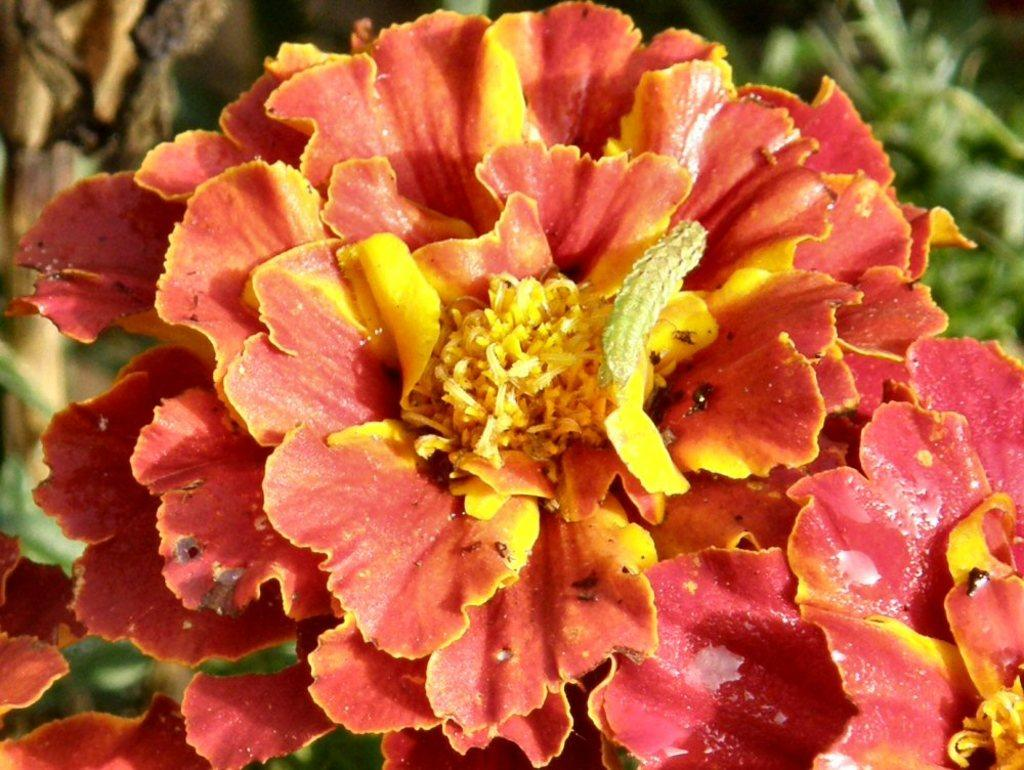What is the main subject of the image? The main subject of the image is a worm. Where is the worm located in the image? The worm is on a flower. How does the worm sleep in the image? The image does not show the worm sleeping, as it is on a flower. 